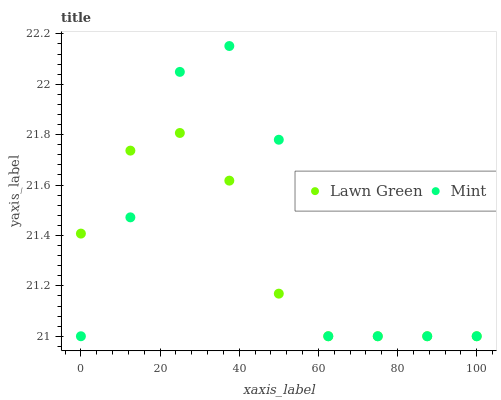Does Lawn Green have the minimum area under the curve?
Answer yes or no. Yes. Does Mint have the maximum area under the curve?
Answer yes or no. Yes. Does Mint have the minimum area under the curve?
Answer yes or no. No. Is Lawn Green the smoothest?
Answer yes or no. Yes. Is Mint the roughest?
Answer yes or no. Yes. Is Mint the smoothest?
Answer yes or no. No. Does Lawn Green have the lowest value?
Answer yes or no. Yes. Does Mint have the highest value?
Answer yes or no. Yes. Does Mint intersect Lawn Green?
Answer yes or no. Yes. Is Mint less than Lawn Green?
Answer yes or no. No. Is Mint greater than Lawn Green?
Answer yes or no. No. 